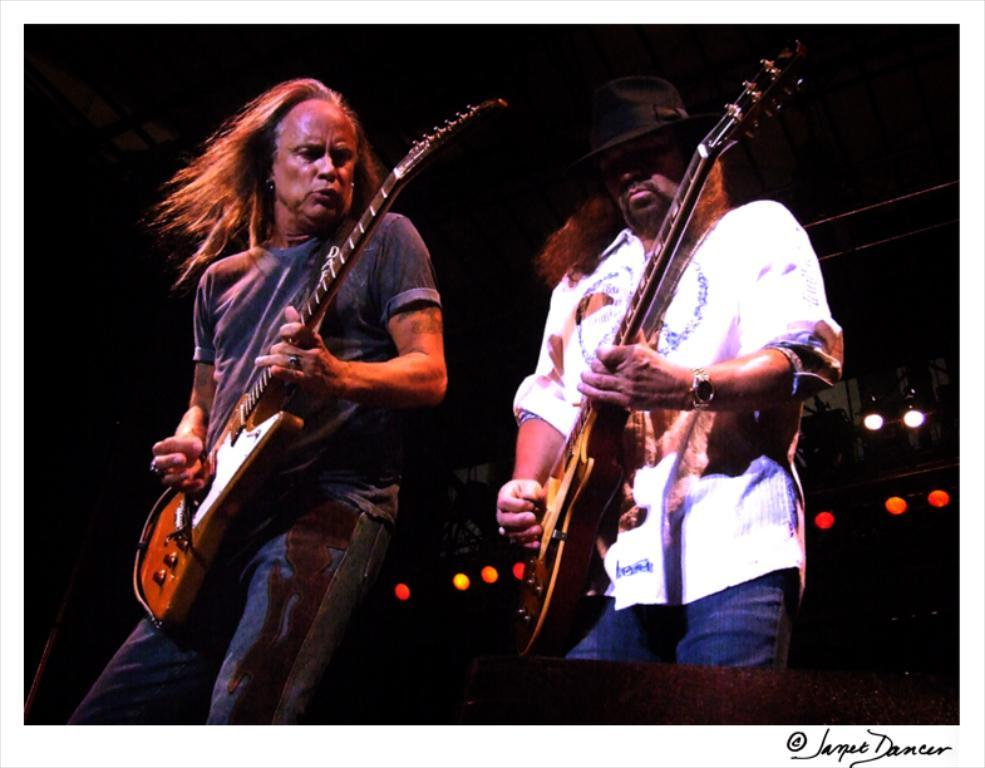How many people are in the image? There are two persons in the image. What are the two persons doing? The two persons are playing guitars. Can you describe any other elements in the image? Yes, there are lights visible in the image. What type of dress is the bucket wearing in the image? There is no bucket or dress present in the image. How many stamps are visible on the guitar in the image? There are no stamps visible on the guitars in the image. 